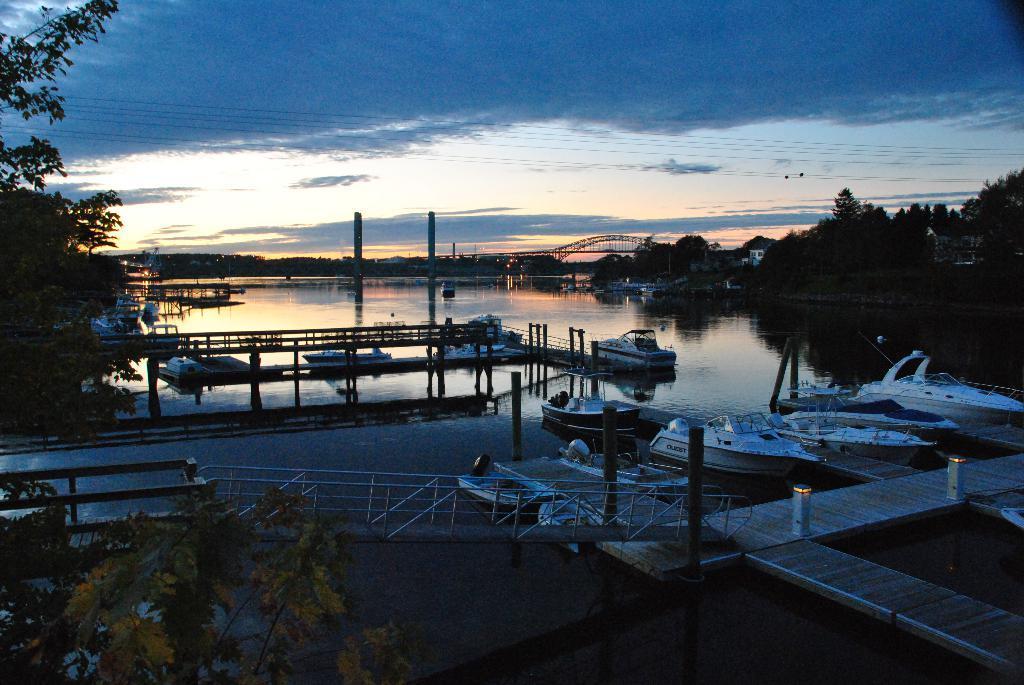How would you summarize this image in a sentence or two? We can see boats above the water, bridge and railing. On the left side of the image we can see trees. In the background we can see trees, bridge, tower, wires and sky with clouds. 